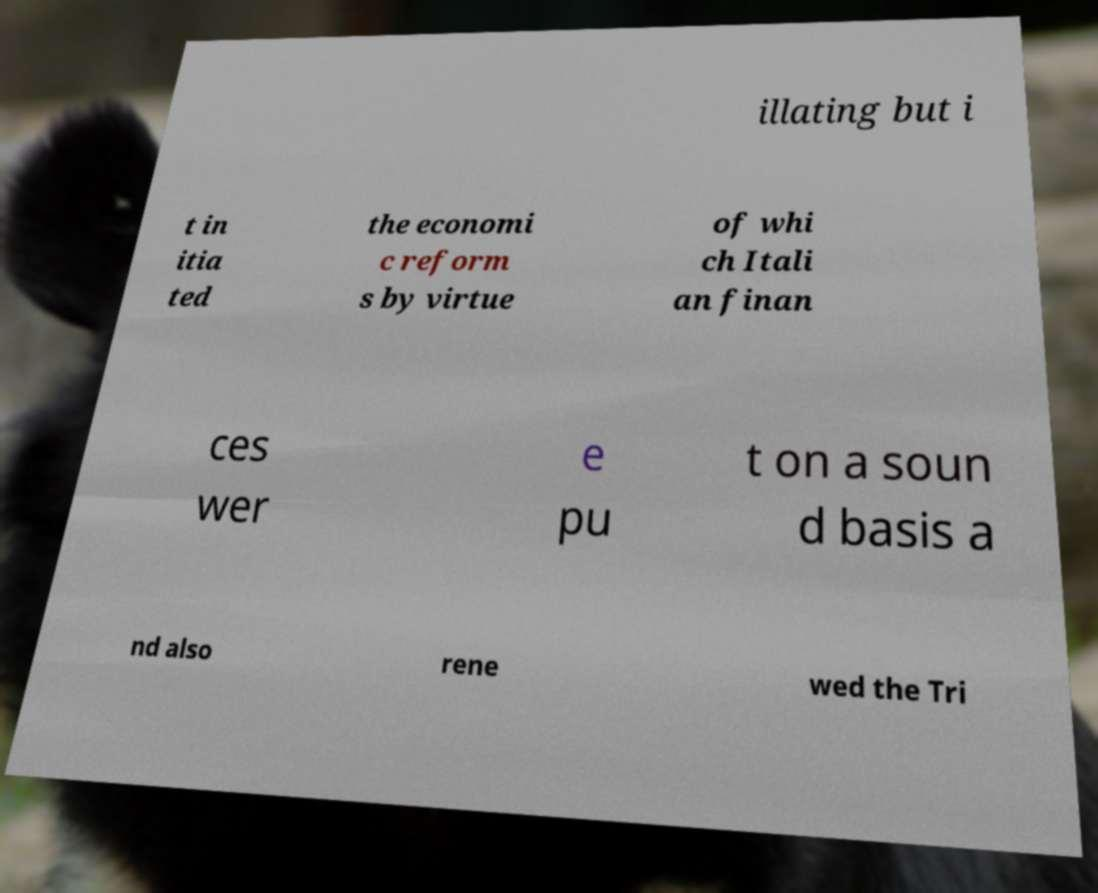Could you assist in decoding the text presented in this image and type it out clearly? illating but i t in itia ted the economi c reform s by virtue of whi ch Itali an finan ces wer e pu t on a soun d basis a nd also rene wed the Tri 